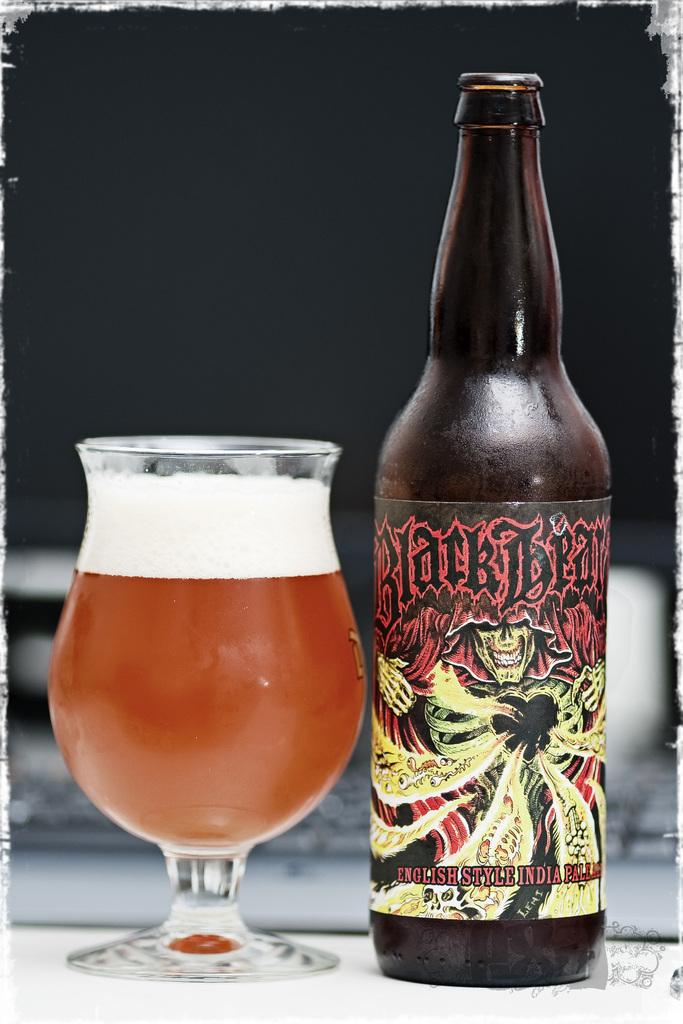<image>
Render a clear and concise summary of the photo. a bottle of black bear standing next to a glass of it on a counter 